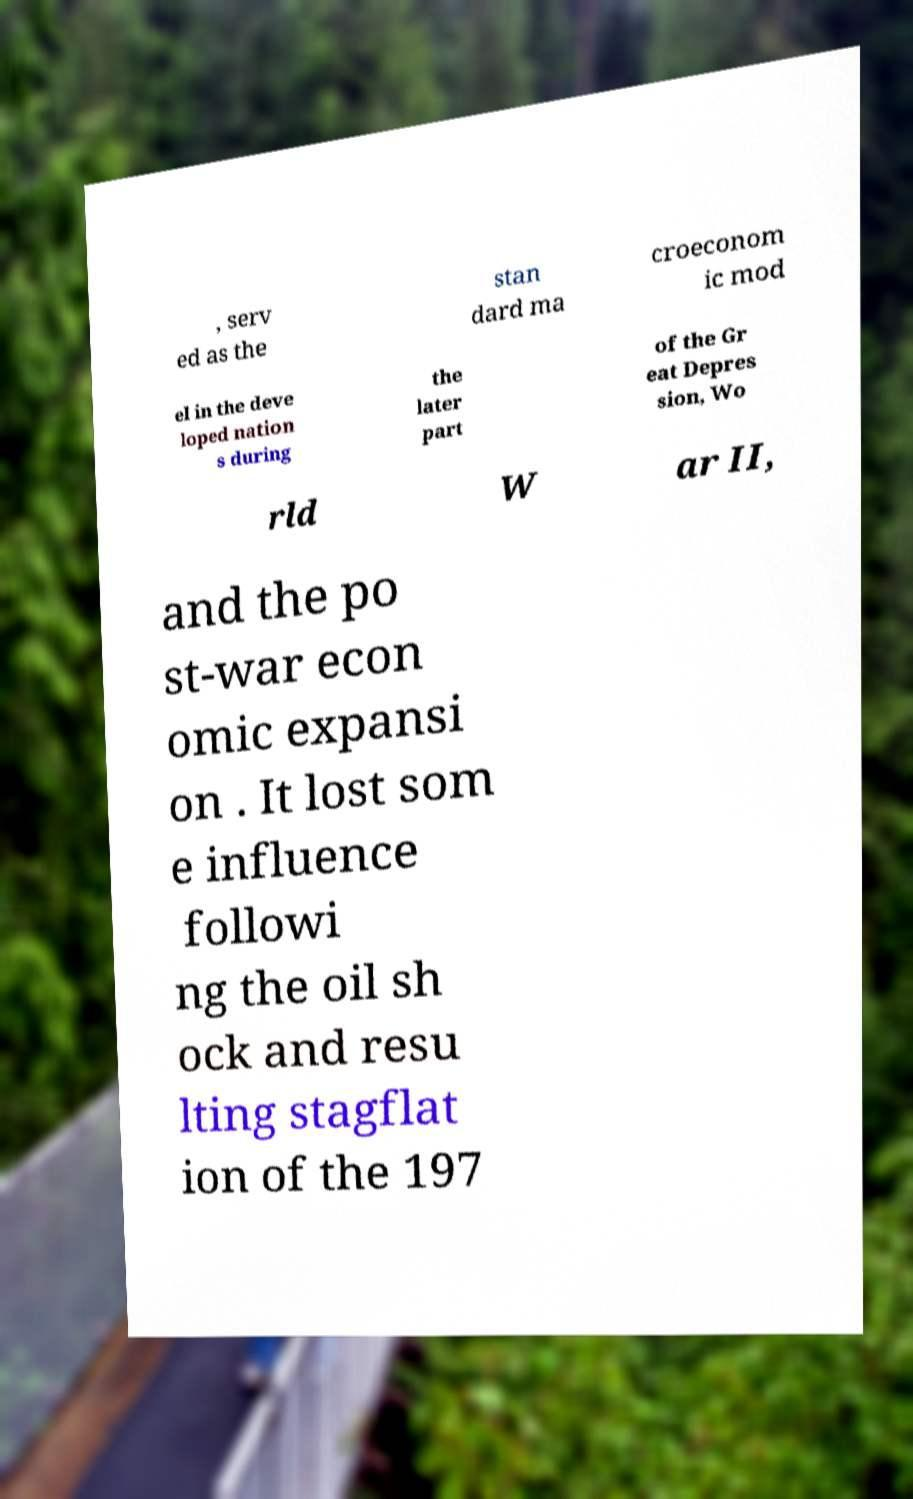Can you read and provide the text displayed in the image?This photo seems to have some interesting text. Can you extract and type it out for me? , serv ed as the stan dard ma croeconom ic mod el in the deve loped nation s during the later part of the Gr eat Depres sion, Wo rld W ar II, and the po st-war econ omic expansi on . It lost som e influence followi ng the oil sh ock and resu lting stagflat ion of the 197 